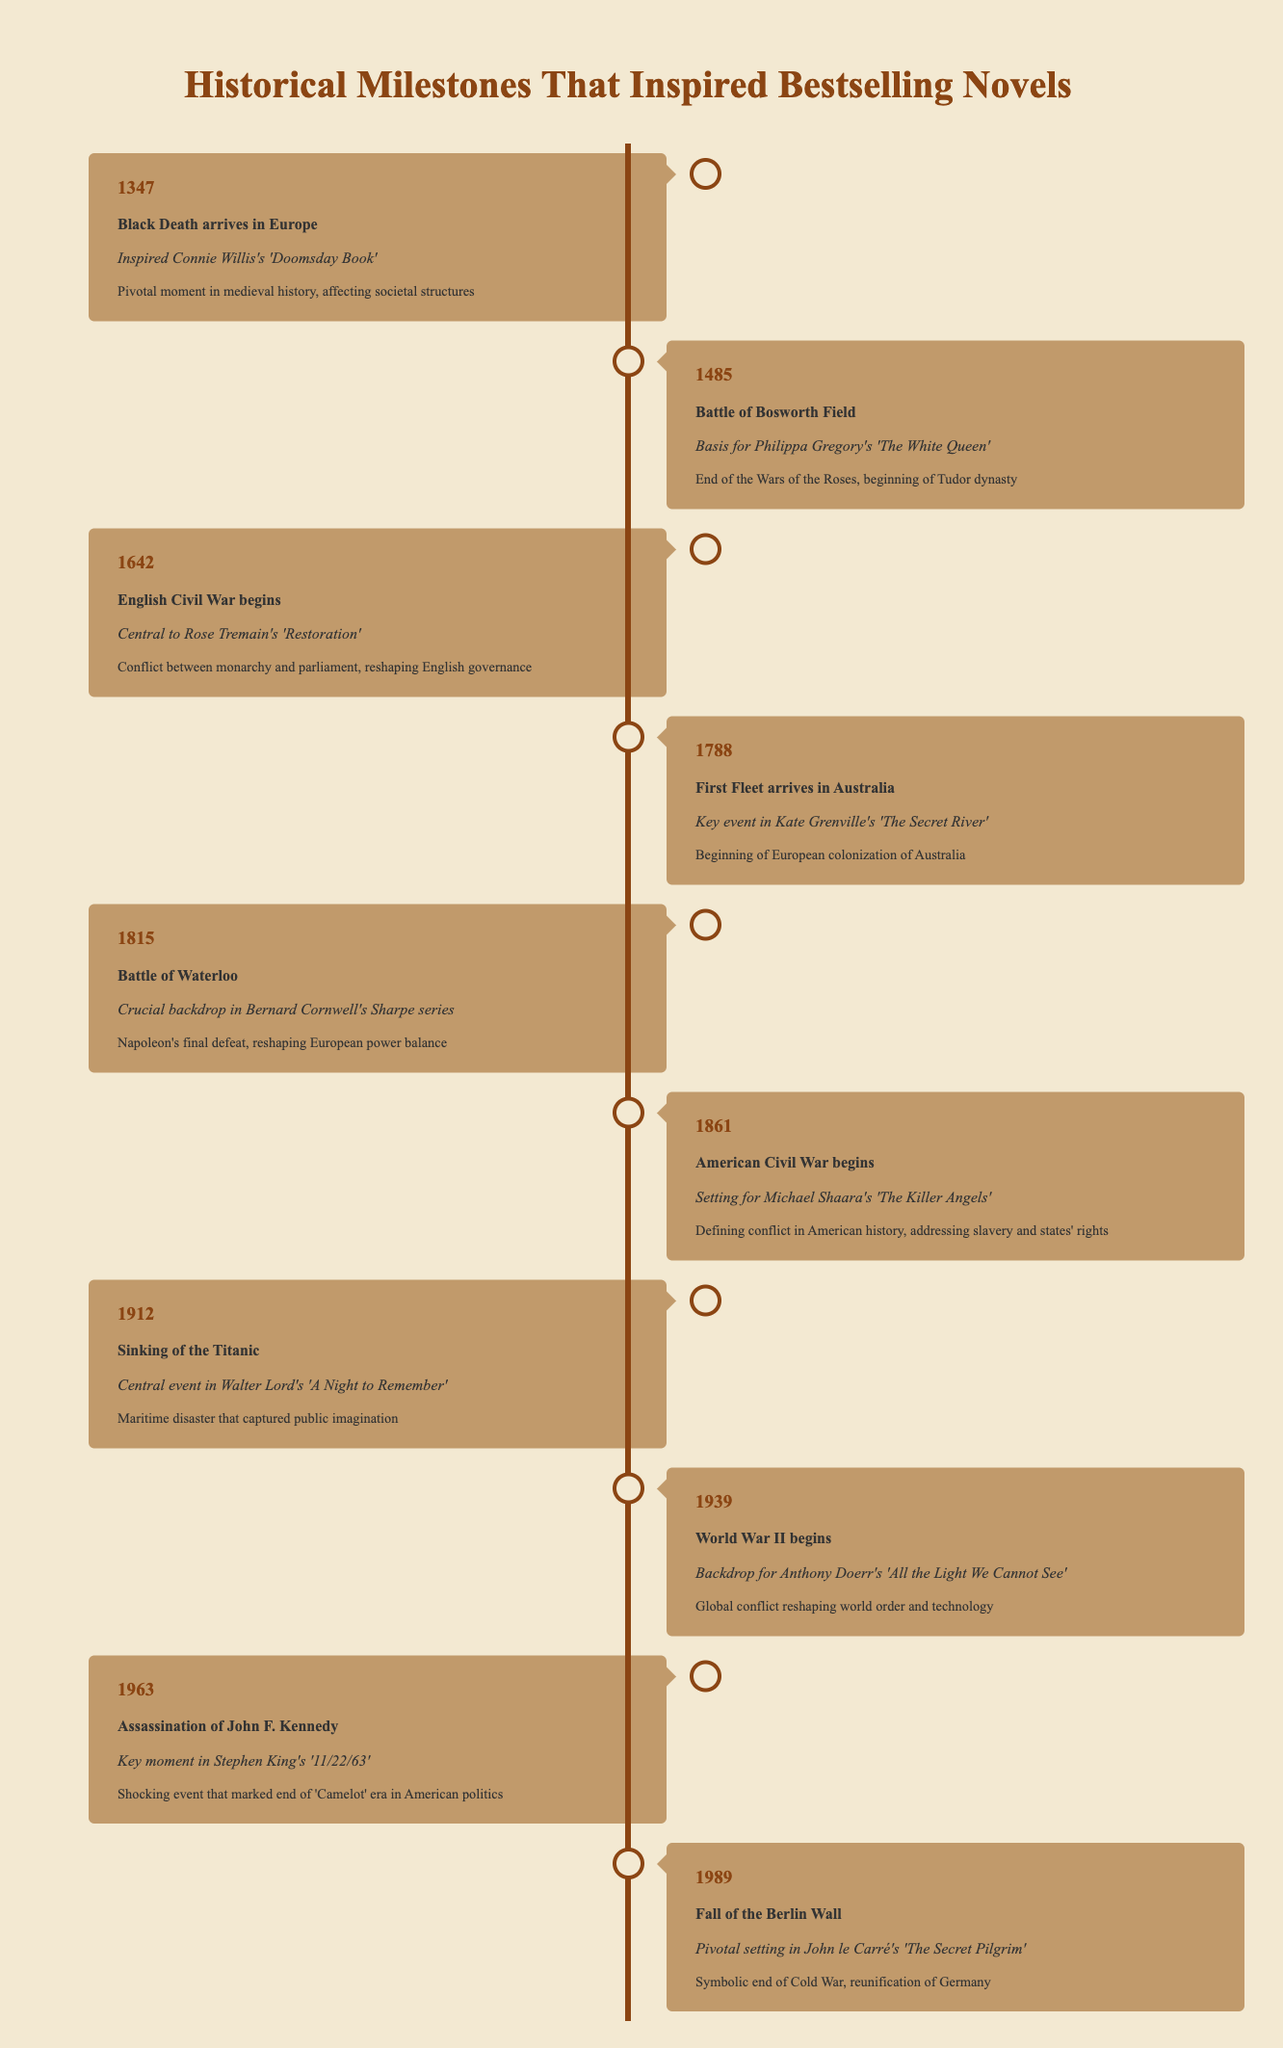What event inspired Connie Willis's 'Doomsday Book'? The table lists the event "Black Death arrives in Europe" in the year 1347, with a corresponding note that it inspired Connie Willis's novel.
Answer: Black Death arrives in Europe What year did the Battle of Waterloo occur? The table indicates that the Battle of Waterloo took place in the year 1815.
Answer: 1815 Which novel is associated with the event of the American Civil War beginning? Referring to the table, it shows that Michael Shaara's novel "The Killer Angels" is based on the American Civil War, which began in 1861.
Answer: The Killer Angels Is the Fall of the Berlin Wall a significant historical event? The table includes the Fall of the Berlin Wall in 1989, marked as a pivotal event; therefore, it indicates its significance.
Answer: Yes Which two events represented the beginning of significant wars in history, according to the table? By analyzing the table, the years 1642 and 1861 show the start of the English Civil War and the American Civil War, respectively. So, both marked beginnings of significant conflict.
Answer: English Civil War and American Civil War What is the significance of the sinking of the Titanic? The table states that the sinking of the Titanic was a maritime disaster that captured public imagination, highlighting its significance in history.
Answer: Maritime disaster that captured public imagination Which event in 1939 had a major impact on the world order? According to the table, World War II began in 1939, and this conflict reshaped the world order, making it a significant event.
Answer: World War II begins How many years passed between the arrival of the First Fleet in Australia and the Fall of the Berlin Wall? The First Fleet arrived in 1788, and the Berlin Wall fell in 1989. Calculating the difference: 1989 - 1788 equals 201 years, indicating a considerable passage of time.
Answer: 201 years What was the common theme among most events listed in this historical timeline? The events listed predominantly relate to wars, conflicts, and significant societal changes, indicating their common theme of pivotal moments in history.
Answer: Significant societal changes and conflicts 